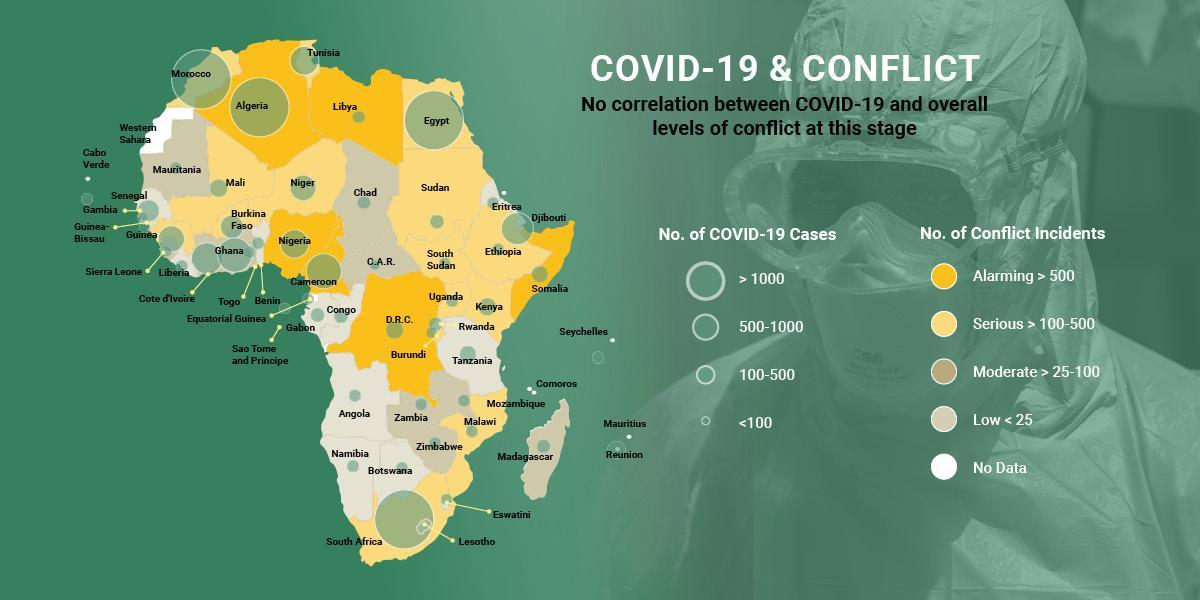What is the number of Covid cases in Niger?
Answer the question with a short phrase. 500-1000 What is the number of Covid cases in Mali? 100-500 What is the number of countries with Covid cases greater than 1000? 4 What is the number of Covid cases in Tunisia? 500-1000 What is the number of Covid cases in D.R.C? 100-500 